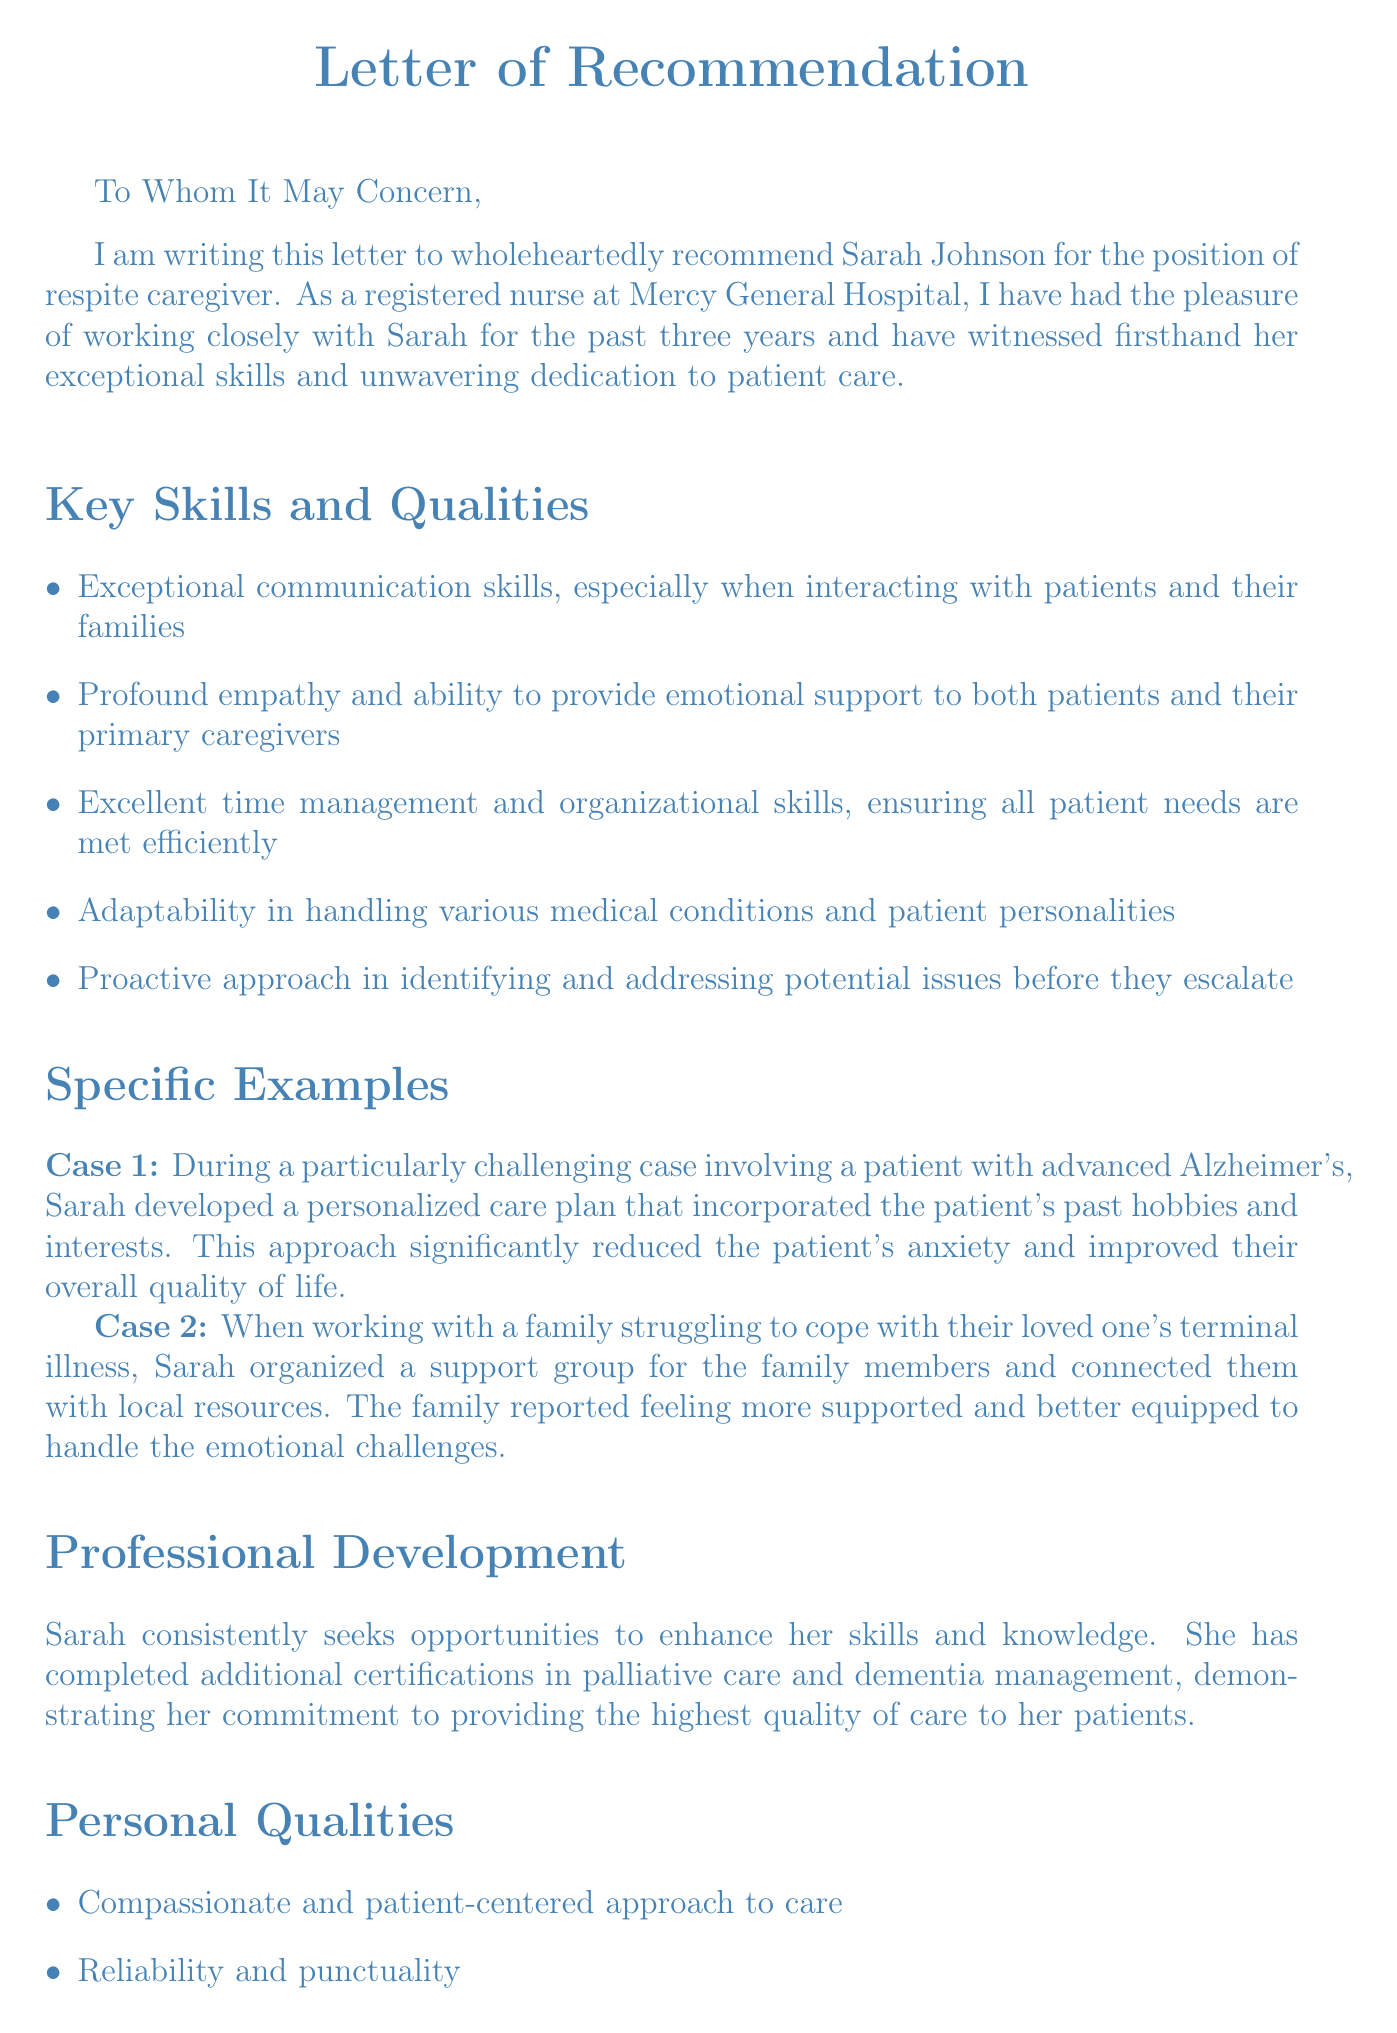What is the name of the recommended caregiver? The letter specifically recommends Sarah Johnson for the position of respite caregiver.
Answer: Sarah Johnson Who is the author of the letter? The letter is authored by Emily Thompson, who is identified as a registered nurse at Mercy General Hospital.
Answer: Emily Thompson How many years has the author worked with the caregiver? The letter mentions that the author has worked closely with Sarah for the past three years.
Answer: three years What is one of Sarah's exceptional skills mentioned in the letter? The letter highlights multiple skills, one of which is "Exceptional communication skills."
Answer: Exceptional communication skills What action did Sarah take for the family struggling with a terminal illness? Sarah organized a support group for the family members and connected them with local resources.
Answer: Organized a support group What additional certifications has Sarah completed? The letter states that she completed certifications in palliative care and dementia management.
Answer: Palliative care and dementia management What personal quality is emphasized in the letter? The letter emphasizes a compassionate and patient-centered approach to care as one of Sarah's personal qualities.
Answer: Compassionate and patient-centered approach What is the author's contact information in the letter? The letter provides Emily Thompson's contact information, which includes a phone number and an email address.
Answer: (555) 123-4567, emily.thompson@mercygeneral.org 